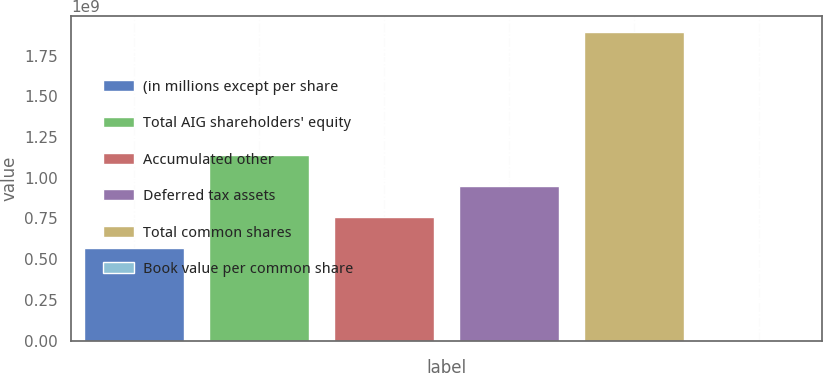Convert chart. <chart><loc_0><loc_0><loc_500><loc_500><bar_chart><fcel>(in millions except per share<fcel>Total AIG shareholders' equity<fcel>Accumulated other<fcel>Deferred tax assets<fcel>Total common shares<fcel>Book value per common share<nl><fcel>5.69046e+08<fcel>1.13809e+09<fcel>7.58729e+08<fcel>9.48411e+08<fcel>1.89682e+09<fcel>39.57<nl></chart> 